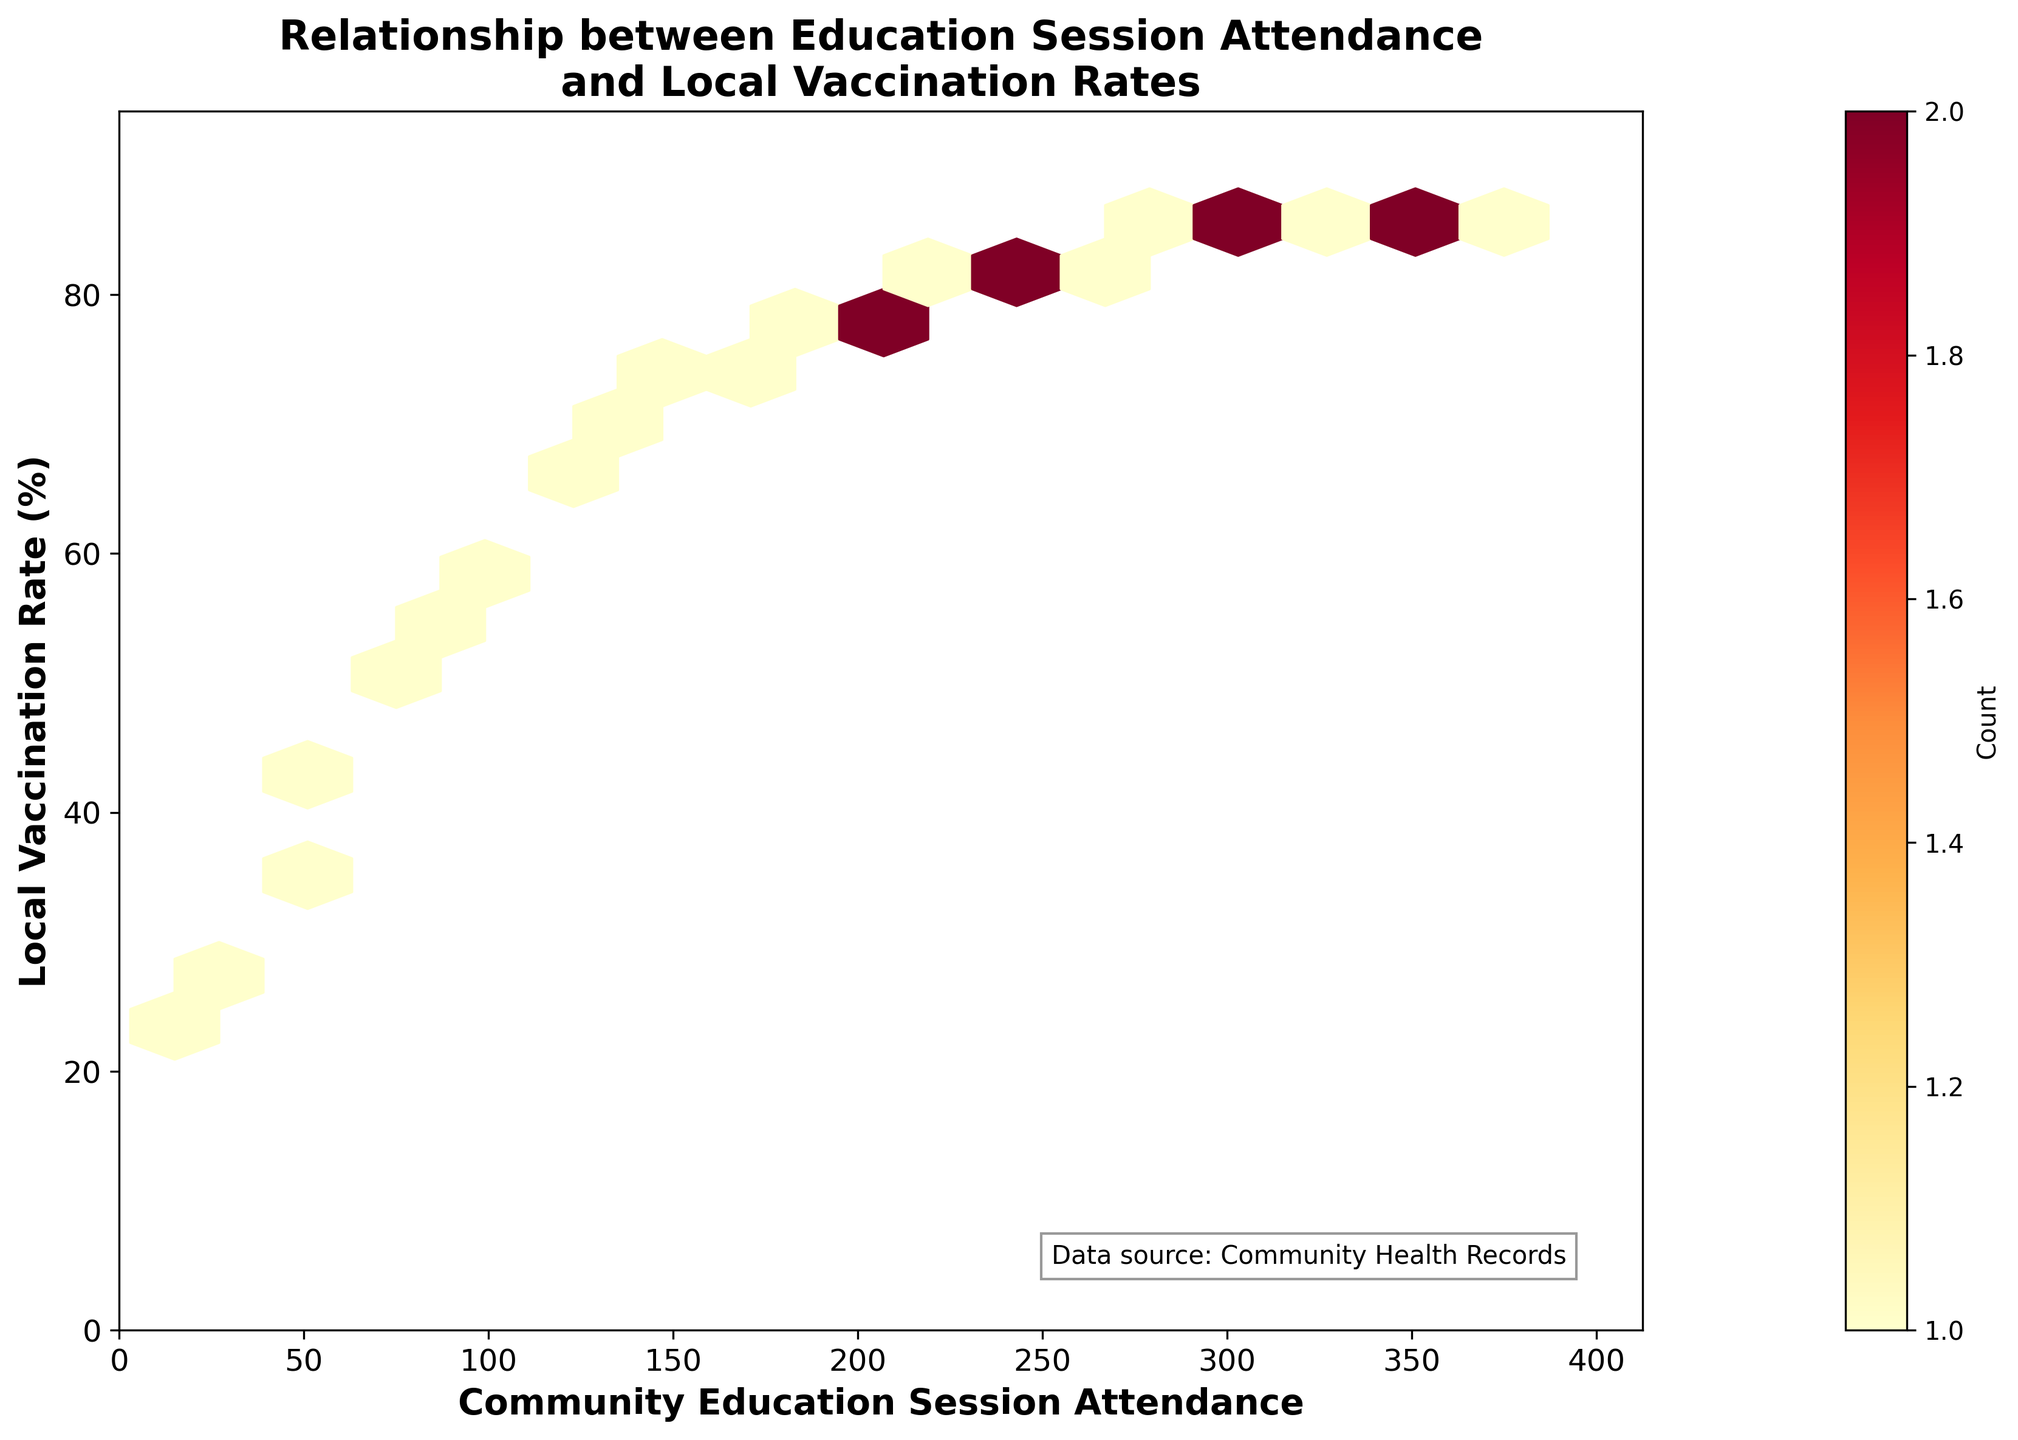What is the title of the Hexbin Plot? The title is displayed at the top center of the plot and reads "Relationship between Education Session Attendance and Local Vaccination Rates".
Answer: Relationship between Education Session Attendance and Local Vaccination Rates Which axis represents the "Community Education Session Attendance"? The x-axis, labeled "Community Education Session Attendance," represents this variable.
Answer: x-axis How many bins indicate a count of more than 1? The color bar shows counts, with each color representing a different count. Most of the bins have colors corresponding to counts greater than 1. By inspecting the hexbin colors in the plot according to the color bar, we can see that many bins show counts greater than 1.
Answer: Most bins What is the approximate range of the "Local Vaccination Rate" in the Hexbin Plot? The y-axis, labeled "Local Vaccination Rate (%)", ranges from 0 to approximately 95%. This is indicated by the upper limit of the y-axis.
Answer: 0 to 95% What is the hexagonal bin color representing the highest count of data points? The color bar indicates that the deepest red color represents the highest count of data points. By referring to the hexagons themselves, the deepest red color is consistent with regions of highest density of points.
Answer: Deepest red Is there a visible relationship between the attendance of community education sessions and local vaccination rates? By observing the density of the hexagonal bins, we see that higher attendance is associated with higher local vaccination rates, indicating a positive relationship.
Answer: Yes Which axis has a label that specifies the unit as a percentage? The y-axis has a label specifying the unit as "Local Vaccination Rate (%)". This includes the percentage sign, indicating the unit.
Answer: y-axis What can you infer about communities with higher education session attendance based on the plot? Communities with higher session attendance tend to have higher vaccination rates. This inference is drawn from the trend observed in the hexagonal bins, where increased session attendance corresponds to increased vaccination rates.
Answer: Higher vaccination rates What is the grid size of the hexagonal bins used in the plot? The grid size can be determined from the plot code, although it's not directly visible in the figure. The plot code indicates a grid size of 15 for the hexagonal bins.
Answer: 15 